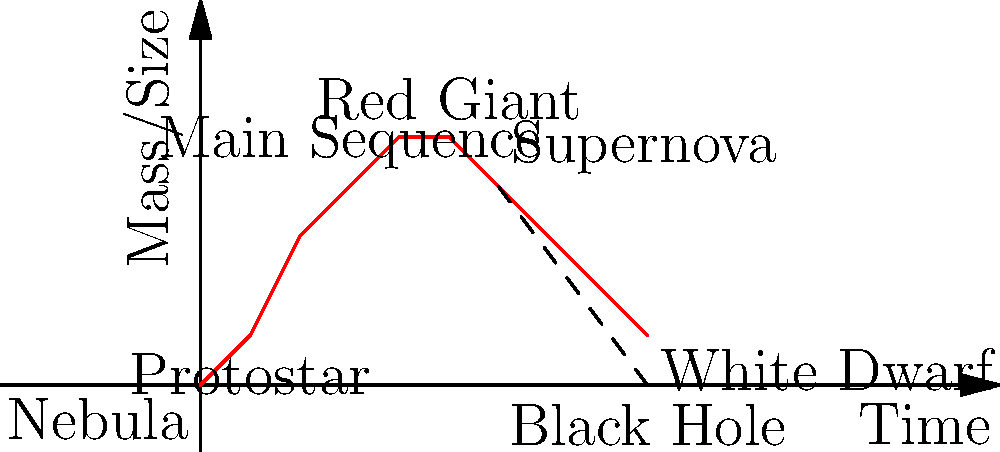In the life cycle of a star, which stage is characterized by the fusion of hydrogen into helium in the core, and how would you represent this stage using Twig templating engine in a PHP-based astronomy website? To answer this question, let's break down the life cycle of a star and how we can represent it using Twig:

1. The life cycle of a star typically follows these stages:
   - Nebula
   - Protostar
   - Main Sequence
   - Red Giant
   - White Dwarf (for smaller stars) or Supernova followed by a Black Hole (for larger stars)

2. The stage characterized by the fusion of hydrogen into helium in the core is the Main Sequence stage. This is the longest and most stable period in a star's life.

3. To represent this using Twig in a PHP-based astronomy website, we could create a template that displays information about each stage. Here's how we might structure it:

   ```twig
   {% set star_stages = [
       {name: 'Nebula', duration: 'Varies'},
       {name: 'Protostar', duration: 'About 100,000 years'},
       {name: 'Main Sequence', duration: 'Billions of years', process: 'Hydrogen fusion'},
       {name: 'Red Giant', duration: 'Millions of years'},
       {name: 'White Dwarf/Black Hole', duration: 'Billions of years'}
   ] %}

   {% for stage in star_stages %}
       <div class="star-stage">
           <h3>{{ stage.name }}</h3>
           <p>Duration: {{ stage.duration }}</p>
           {% if stage.process is defined %}
               <p>Main Process: {{ stage.process }}</p>
           {% endif %}
       </div>
   {% endfor %}
   ```

4. In this Twig template, we've defined an array of star stages. The Main Sequence stage includes the 'process' key, which specifies "Hydrogen fusion".

5. The template then loops through each stage, creating a div for each one. If the stage has a defined process (which only the Main Sequence does in this case), it displays that information.

This approach allows for a dynamic representation of the star life cycle, with the Main Sequence stage clearly identified by its unique process of hydrogen fusion.
Answer: Main Sequence 